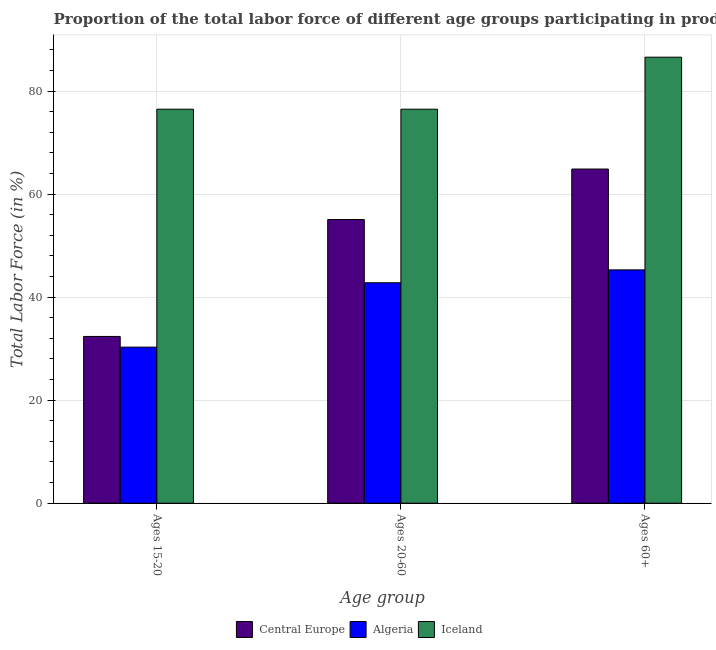How many groups of bars are there?
Give a very brief answer. 3. Are the number of bars per tick equal to the number of legend labels?
Give a very brief answer. Yes. What is the label of the 3rd group of bars from the left?
Your response must be concise. Ages 60+. What is the percentage of labor force within the age group 20-60 in Iceland?
Your response must be concise. 76.5. Across all countries, what is the maximum percentage of labor force within the age group 20-60?
Make the answer very short. 76.5. Across all countries, what is the minimum percentage of labor force within the age group 15-20?
Offer a very short reply. 30.3. In which country was the percentage of labor force within the age group 15-20 maximum?
Your answer should be very brief. Iceland. In which country was the percentage of labor force within the age group 20-60 minimum?
Keep it short and to the point. Algeria. What is the total percentage of labor force above age 60 in the graph?
Your answer should be very brief. 196.78. What is the difference between the percentage of labor force within the age group 15-20 in Algeria and that in Central Europe?
Your response must be concise. -2.08. What is the difference between the percentage of labor force above age 60 in Central Europe and the percentage of labor force within the age group 20-60 in Algeria?
Offer a terse response. 22.08. What is the average percentage of labor force within the age group 15-20 per country?
Your answer should be very brief. 46.39. What is the difference between the percentage of labor force above age 60 and percentage of labor force within the age group 20-60 in Iceland?
Ensure brevity in your answer.  10.1. What is the ratio of the percentage of labor force within the age group 15-20 in Central Europe to that in Algeria?
Your response must be concise. 1.07. Is the percentage of labor force above age 60 in Algeria less than that in Central Europe?
Give a very brief answer. Yes. What is the difference between the highest and the second highest percentage of labor force within the age group 15-20?
Provide a succinct answer. 44.12. What is the difference between the highest and the lowest percentage of labor force above age 60?
Make the answer very short. 41.3. In how many countries, is the percentage of labor force above age 60 greater than the average percentage of labor force above age 60 taken over all countries?
Keep it short and to the point. 1. Is the sum of the percentage of labor force above age 60 in Algeria and Central Europe greater than the maximum percentage of labor force within the age group 20-60 across all countries?
Offer a terse response. Yes. What does the 1st bar from the left in Ages 60+ represents?
Ensure brevity in your answer.  Central Europe. What does the 3rd bar from the right in Ages 20-60 represents?
Provide a succinct answer. Central Europe. How many bars are there?
Your answer should be compact. 9. Does the graph contain grids?
Give a very brief answer. Yes. How are the legend labels stacked?
Your answer should be very brief. Horizontal. What is the title of the graph?
Ensure brevity in your answer.  Proportion of the total labor force of different age groups participating in production in 2007. What is the label or title of the X-axis?
Give a very brief answer. Age group. What is the label or title of the Y-axis?
Your answer should be compact. Total Labor Force (in %). What is the Total Labor Force (in %) of Central Europe in Ages 15-20?
Give a very brief answer. 32.38. What is the Total Labor Force (in %) in Algeria in Ages 15-20?
Your answer should be compact. 30.3. What is the Total Labor Force (in %) of Iceland in Ages 15-20?
Make the answer very short. 76.5. What is the Total Labor Force (in %) in Central Europe in Ages 20-60?
Give a very brief answer. 55.08. What is the Total Labor Force (in %) of Algeria in Ages 20-60?
Ensure brevity in your answer.  42.8. What is the Total Labor Force (in %) in Iceland in Ages 20-60?
Make the answer very short. 76.5. What is the Total Labor Force (in %) in Central Europe in Ages 60+?
Provide a succinct answer. 64.88. What is the Total Labor Force (in %) in Algeria in Ages 60+?
Keep it short and to the point. 45.3. What is the Total Labor Force (in %) of Iceland in Ages 60+?
Provide a short and direct response. 86.6. Across all Age group, what is the maximum Total Labor Force (in %) in Central Europe?
Provide a short and direct response. 64.88. Across all Age group, what is the maximum Total Labor Force (in %) in Algeria?
Give a very brief answer. 45.3. Across all Age group, what is the maximum Total Labor Force (in %) in Iceland?
Provide a short and direct response. 86.6. Across all Age group, what is the minimum Total Labor Force (in %) in Central Europe?
Give a very brief answer. 32.38. Across all Age group, what is the minimum Total Labor Force (in %) in Algeria?
Keep it short and to the point. 30.3. Across all Age group, what is the minimum Total Labor Force (in %) of Iceland?
Offer a very short reply. 76.5. What is the total Total Labor Force (in %) of Central Europe in the graph?
Offer a terse response. 152.33. What is the total Total Labor Force (in %) in Algeria in the graph?
Offer a very short reply. 118.4. What is the total Total Labor Force (in %) of Iceland in the graph?
Provide a succinct answer. 239.6. What is the difference between the Total Labor Force (in %) in Central Europe in Ages 15-20 and that in Ages 20-60?
Give a very brief answer. -22.7. What is the difference between the Total Labor Force (in %) in Iceland in Ages 15-20 and that in Ages 20-60?
Make the answer very short. 0. What is the difference between the Total Labor Force (in %) of Central Europe in Ages 15-20 and that in Ages 60+?
Offer a terse response. -32.5. What is the difference between the Total Labor Force (in %) in Central Europe in Ages 20-60 and that in Ages 60+?
Ensure brevity in your answer.  -9.8. What is the difference between the Total Labor Force (in %) in Algeria in Ages 20-60 and that in Ages 60+?
Offer a terse response. -2.5. What is the difference between the Total Labor Force (in %) in Iceland in Ages 20-60 and that in Ages 60+?
Give a very brief answer. -10.1. What is the difference between the Total Labor Force (in %) in Central Europe in Ages 15-20 and the Total Labor Force (in %) in Algeria in Ages 20-60?
Provide a short and direct response. -10.42. What is the difference between the Total Labor Force (in %) of Central Europe in Ages 15-20 and the Total Labor Force (in %) of Iceland in Ages 20-60?
Your response must be concise. -44.12. What is the difference between the Total Labor Force (in %) in Algeria in Ages 15-20 and the Total Labor Force (in %) in Iceland in Ages 20-60?
Your answer should be compact. -46.2. What is the difference between the Total Labor Force (in %) in Central Europe in Ages 15-20 and the Total Labor Force (in %) in Algeria in Ages 60+?
Provide a succinct answer. -12.92. What is the difference between the Total Labor Force (in %) of Central Europe in Ages 15-20 and the Total Labor Force (in %) of Iceland in Ages 60+?
Provide a succinct answer. -54.22. What is the difference between the Total Labor Force (in %) of Algeria in Ages 15-20 and the Total Labor Force (in %) of Iceland in Ages 60+?
Give a very brief answer. -56.3. What is the difference between the Total Labor Force (in %) in Central Europe in Ages 20-60 and the Total Labor Force (in %) in Algeria in Ages 60+?
Give a very brief answer. 9.78. What is the difference between the Total Labor Force (in %) in Central Europe in Ages 20-60 and the Total Labor Force (in %) in Iceland in Ages 60+?
Keep it short and to the point. -31.52. What is the difference between the Total Labor Force (in %) of Algeria in Ages 20-60 and the Total Labor Force (in %) of Iceland in Ages 60+?
Ensure brevity in your answer.  -43.8. What is the average Total Labor Force (in %) in Central Europe per Age group?
Provide a succinct answer. 50.78. What is the average Total Labor Force (in %) of Algeria per Age group?
Provide a short and direct response. 39.47. What is the average Total Labor Force (in %) of Iceland per Age group?
Provide a succinct answer. 79.87. What is the difference between the Total Labor Force (in %) of Central Europe and Total Labor Force (in %) of Algeria in Ages 15-20?
Your response must be concise. 2.08. What is the difference between the Total Labor Force (in %) of Central Europe and Total Labor Force (in %) of Iceland in Ages 15-20?
Give a very brief answer. -44.12. What is the difference between the Total Labor Force (in %) of Algeria and Total Labor Force (in %) of Iceland in Ages 15-20?
Your response must be concise. -46.2. What is the difference between the Total Labor Force (in %) in Central Europe and Total Labor Force (in %) in Algeria in Ages 20-60?
Give a very brief answer. 12.28. What is the difference between the Total Labor Force (in %) of Central Europe and Total Labor Force (in %) of Iceland in Ages 20-60?
Your response must be concise. -21.42. What is the difference between the Total Labor Force (in %) in Algeria and Total Labor Force (in %) in Iceland in Ages 20-60?
Your response must be concise. -33.7. What is the difference between the Total Labor Force (in %) in Central Europe and Total Labor Force (in %) in Algeria in Ages 60+?
Your response must be concise. 19.58. What is the difference between the Total Labor Force (in %) in Central Europe and Total Labor Force (in %) in Iceland in Ages 60+?
Offer a terse response. -21.72. What is the difference between the Total Labor Force (in %) of Algeria and Total Labor Force (in %) of Iceland in Ages 60+?
Ensure brevity in your answer.  -41.3. What is the ratio of the Total Labor Force (in %) in Central Europe in Ages 15-20 to that in Ages 20-60?
Your answer should be very brief. 0.59. What is the ratio of the Total Labor Force (in %) in Algeria in Ages 15-20 to that in Ages 20-60?
Offer a very short reply. 0.71. What is the ratio of the Total Labor Force (in %) of Iceland in Ages 15-20 to that in Ages 20-60?
Offer a terse response. 1. What is the ratio of the Total Labor Force (in %) of Central Europe in Ages 15-20 to that in Ages 60+?
Provide a short and direct response. 0.5. What is the ratio of the Total Labor Force (in %) in Algeria in Ages 15-20 to that in Ages 60+?
Offer a terse response. 0.67. What is the ratio of the Total Labor Force (in %) of Iceland in Ages 15-20 to that in Ages 60+?
Your answer should be very brief. 0.88. What is the ratio of the Total Labor Force (in %) of Central Europe in Ages 20-60 to that in Ages 60+?
Provide a succinct answer. 0.85. What is the ratio of the Total Labor Force (in %) in Algeria in Ages 20-60 to that in Ages 60+?
Offer a terse response. 0.94. What is the ratio of the Total Labor Force (in %) in Iceland in Ages 20-60 to that in Ages 60+?
Provide a succinct answer. 0.88. What is the difference between the highest and the second highest Total Labor Force (in %) of Central Europe?
Your answer should be very brief. 9.8. What is the difference between the highest and the second highest Total Labor Force (in %) of Algeria?
Provide a short and direct response. 2.5. What is the difference between the highest and the second highest Total Labor Force (in %) in Iceland?
Your answer should be compact. 10.1. What is the difference between the highest and the lowest Total Labor Force (in %) in Central Europe?
Ensure brevity in your answer.  32.5. What is the difference between the highest and the lowest Total Labor Force (in %) of Algeria?
Offer a very short reply. 15. 